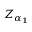Convert formula to latex. <formula><loc_0><loc_0><loc_500><loc_500>Z _ { \alpha _ { 1 } }</formula> 